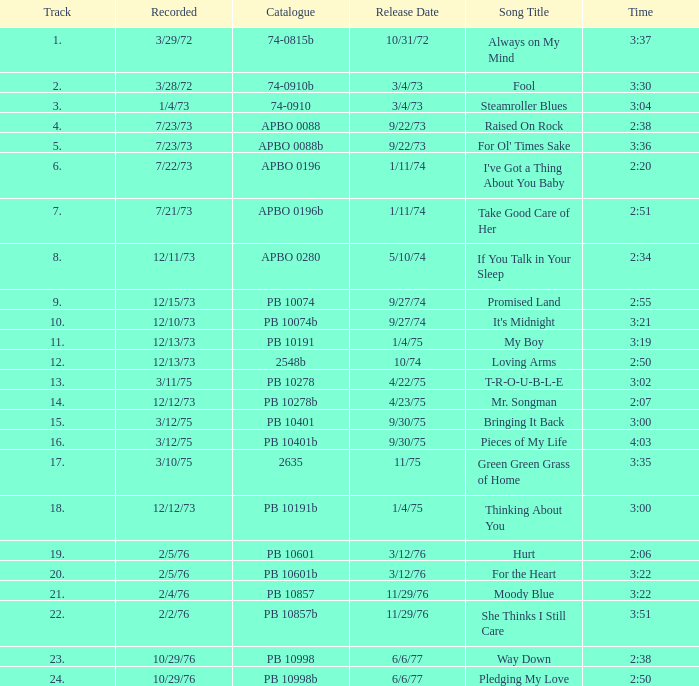Tell me the track that has the catalogue of apbo 0280 8.0. 